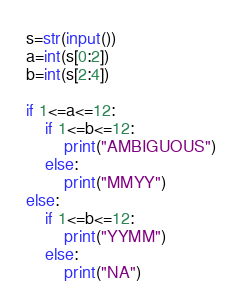Convert code to text. <code><loc_0><loc_0><loc_500><loc_500><_Python_>s=str(input())
a=int(s[0:2])
b=int(s[2:4])

if 1<=a<=12:
    if 1<=b<=12:
        print("AMBIGUOUS")
    else:
        print("MMYY")
else:
    if 1<=b<=12:
        print("YYMM")
    else:
        print("NA")</code> 